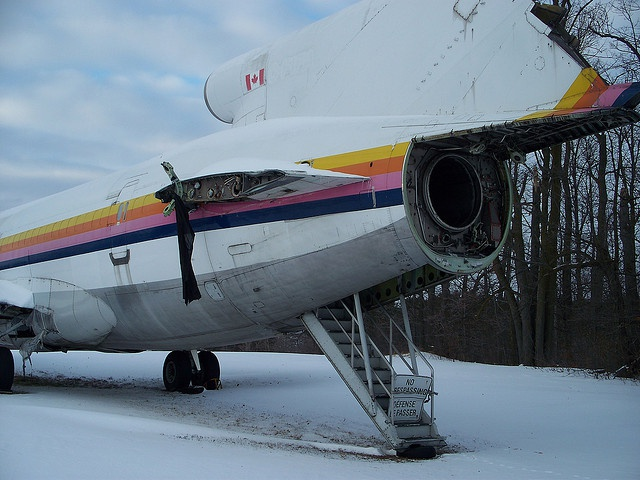Describe the objects in this image and their specific colors. I can see a airplane in gray, black, lightblue, and darkgray tones in this image. 